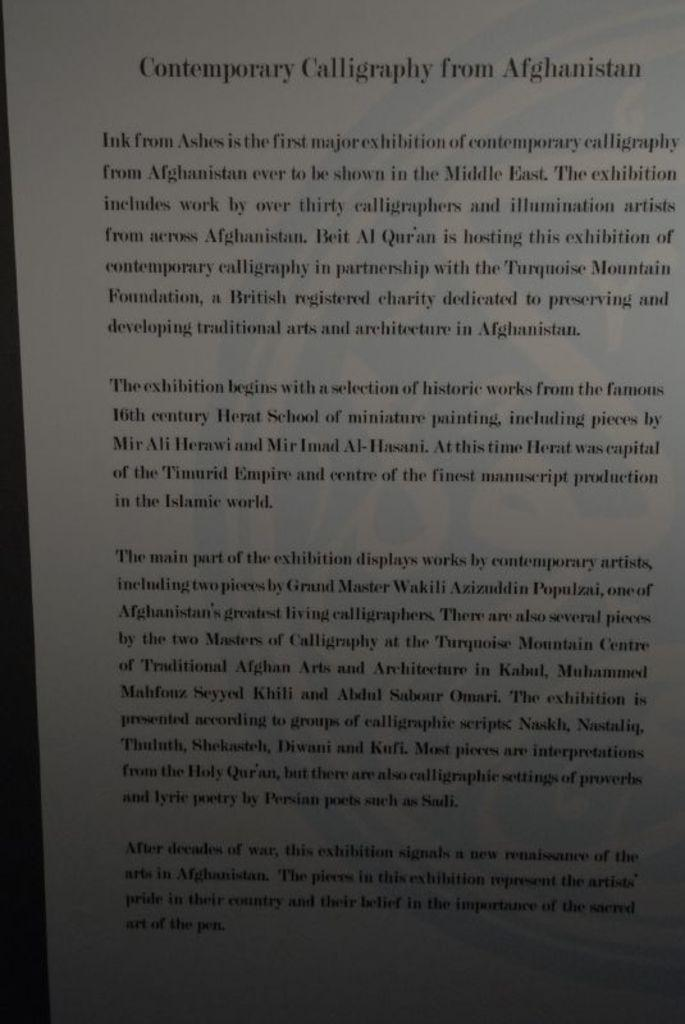<image>
Summarize the visual content of the image. A page of text titled Contemporary Calligraphy from Afghanistan. 